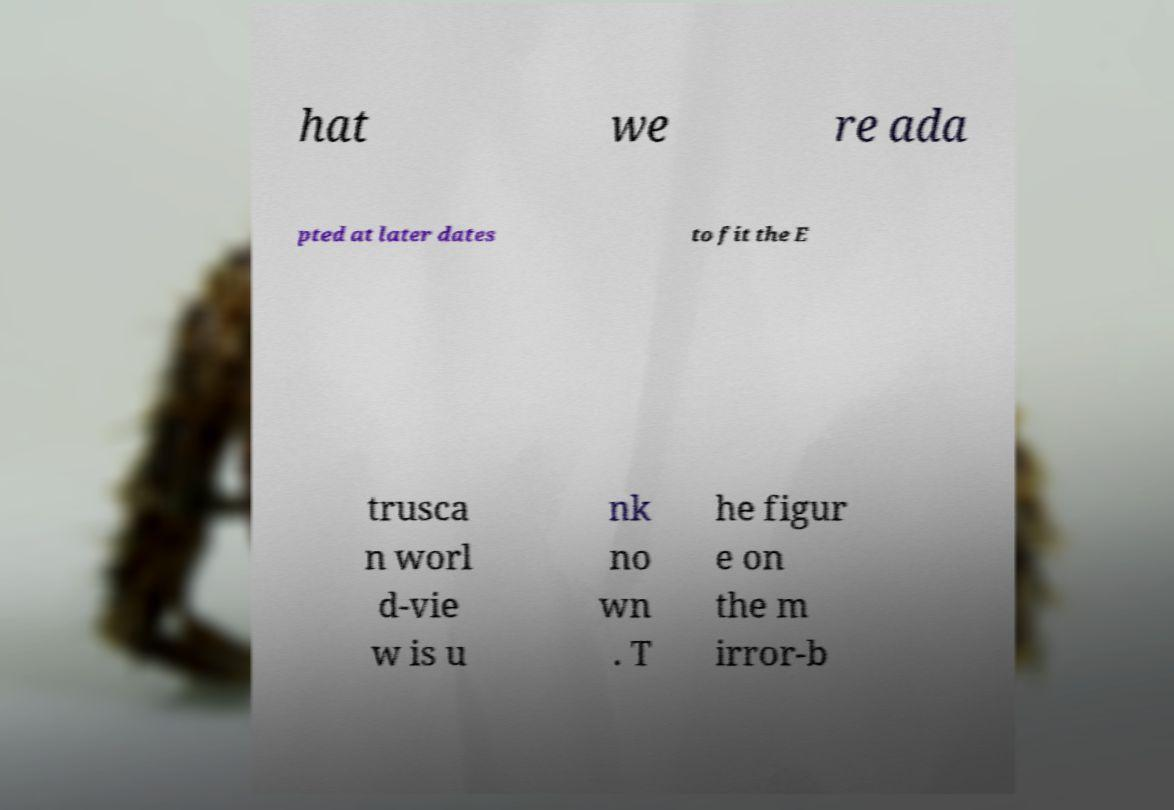What messages or text are displayed in this image? I need them in a readable, typed format. hat we re ada pted at later dates to fit the E trusca n worl d-vie w is u nk no wn . T he figur e on the m irror-b 